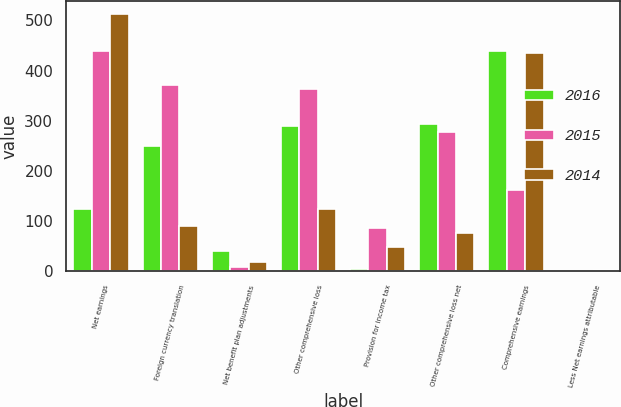<chart> <loc_0><loc_0><loc_500><loc_500><stacked_bar_chart><ecel><fcel>Net earnings<fcel>Foreign currency translation<fcel>Net benefit plan adjustments<fcel>Other comprehensive loss<fcel>Provision for income tax<fcel>Other comprehensive loss net<fcel>Comprehensive earnings<fcel>Less Net earnings attributable<nl><fcel>2016<fcel>124.4<fcel>250<fcel>40.3<fcel>290.3<fcel>3.8<fcel>294.1<fcel>439.1<fcel>1.1<nl><fcel>2015<fcel>438.7<fcel>370.7<fcel>7.7<fcel>363.1<fcel>86.6<fcel>276.5<fcel>162.2<fcel>1.1<nl><fcel>2014<fcel>512.6<fcel>89.5<fcel>18.6<fcel>124.4<fcel>47.7<fcel>76.7<fcel>435.9<fcel>1.4<nl></chart> 